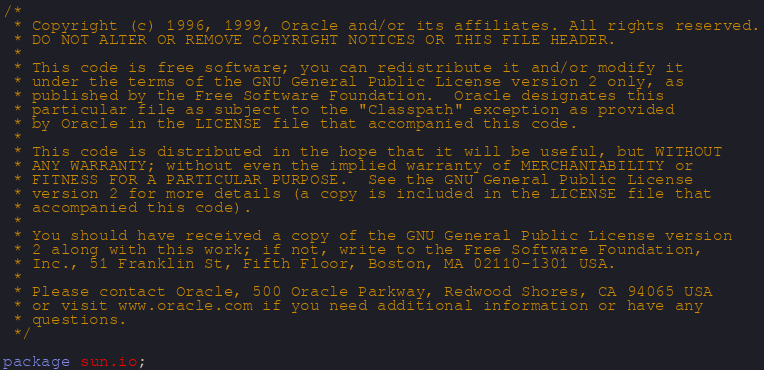<code> <loc_0><loc_0><loc_500><loc_500><_Java_>/*
 * Copyright (c) 1996, 1999, Oracle and/or its affiliates. All rights reserved.
 * DO NOT ALTER OR REMOVE COPYRIGHT NOTICES OR THIS FILE HEADER.
 *
 * This code is free software; you can redistribute it and/or modify it
 * under the terms of the GNU General Public License version 2 only, as
 * published by the Free Software Foundation.  Oracle designates this
 * particular file as subject to the "Classpath" exception as provided
 * by Oracle in the LICENSE file that accompanied this code.
 *
 * This code is distributed in the hope that it will be useful, but WITHOUT
 * ANY WARRANTY; without even the implied warranty of MERCHANTABILITY or
 * FITNESS FOR A PARTICULAR PURPOSE.  See the GNU General Public License
 * version 2 for more details (a copy is included in the LICENSE file that
 * accompanied this code).
 *
 * You should have received a copy of the GNU General Public License version
 * 2 along with this work; if not, write to the Free Software Foundation,
 * Inc., 51 Franklin St, Fifth Floor, Boston, MA 02110-1301 USA.
 *
 * Please contact Oracle, 500 Oracle Parkway, Redwood Shores, CA 94065 USA
 * or visit www.oracle.com if you need additional information or have any
 * questions.
 */

package sun.io;</code> 